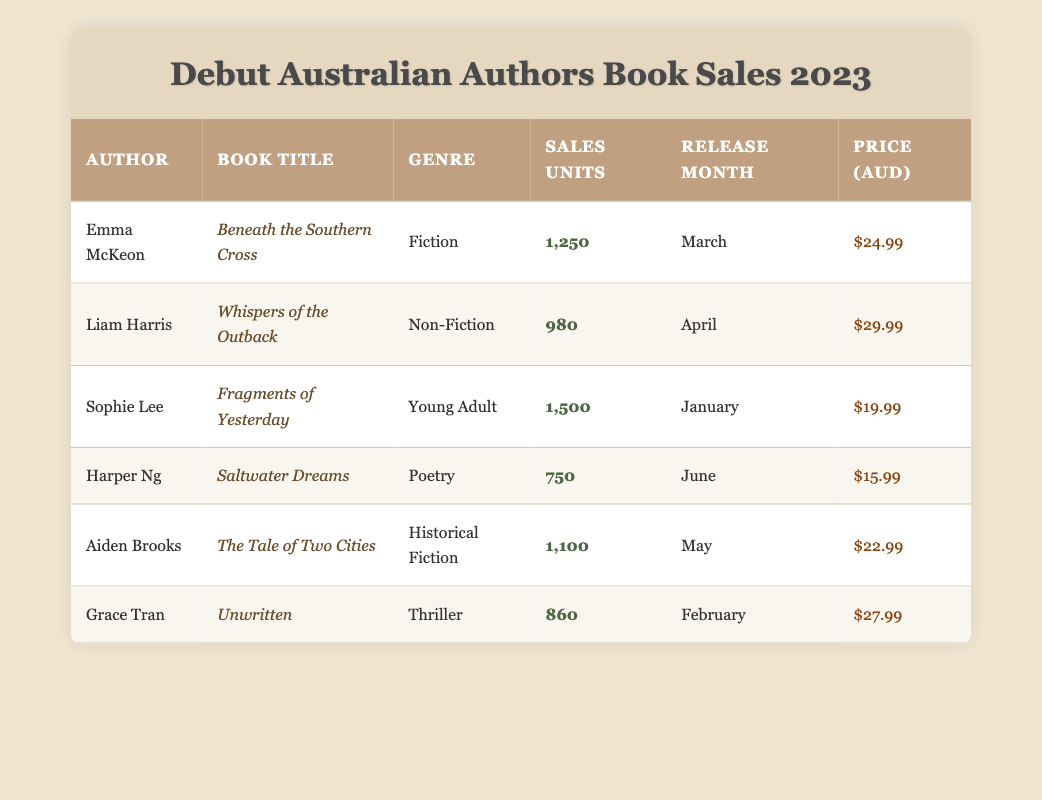What is the book title with the highest sales units? The table shows the sales units for each book, and "Fragments of Yesterday" by Sophie Lee has the highest sales with 1500 units.
Answer: Fragments of Yesterday Which author released their book in April? Looking at the release month column, "Whispers of the Outback" by Liam Harris is the only book listed under April.
Answer: Liam Harris What is the average price of the books listed? The total price of all books is calculated by adding them: (24.99 + 29.99 + 19.99 + 15.99 + 22.99 + 27.99) = 140.94. There are 6 books, so the average price is 140.94/6 = 23.49.
Answer: 23.49 Is there a book in the genre of poetry? The table lists "Saltwater Dreams" by Harper Ng under the genre of Poetry, confirming that there is indeed a book in this genre.
Answer: Yes Which two authors had sales units within the range of 800 to 1200? By examining the sales units, "Beneath the Southern Cross" by Emma McKeon (1250) and "The Tale of Two Cities" by Aiden Brooks (1100) are the only two books with sales within 800 and 1200.
Answer: Emma McKeon, Aiden Brooks What is the total sales units for all the books listed? We add up all the sales units: 1250 + 980 + 1500 + 750 + 1100 + 860 = 5640, which gives us the total sales units for all books.
Answer: 5640 Who is the author of "Unwritten"? The table directly indicates that "Unwritten" is written by Grace Tran.
Answer: Grace Tran How many books were released after March? The books released after March are "Whispers of the Outback" (April), "The Tale of Two Cities" (May), "Saltwater Dreams" (June). This totals 3 books.
Answer: 3 